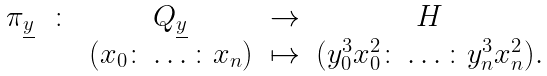<formula> <loc_0><loc_0><loc_500><loc_500>\begin{array} { c c c c c } \pi _ { \underline { y } } & \colon & Q _ { \underline { y } } & \rightarrow & H \\ & & ( x _ { 0 } \colon \dots \colon x _ { n } ) & \mapsto & ( y _ { 0 } ^ { 3 } x _ { 0 } ^ { 2 } \colon \dots \colon y _ { n } ^ { 3 } x _ { n } ^ { 2 } ) . \\ \end{array}</formula> 